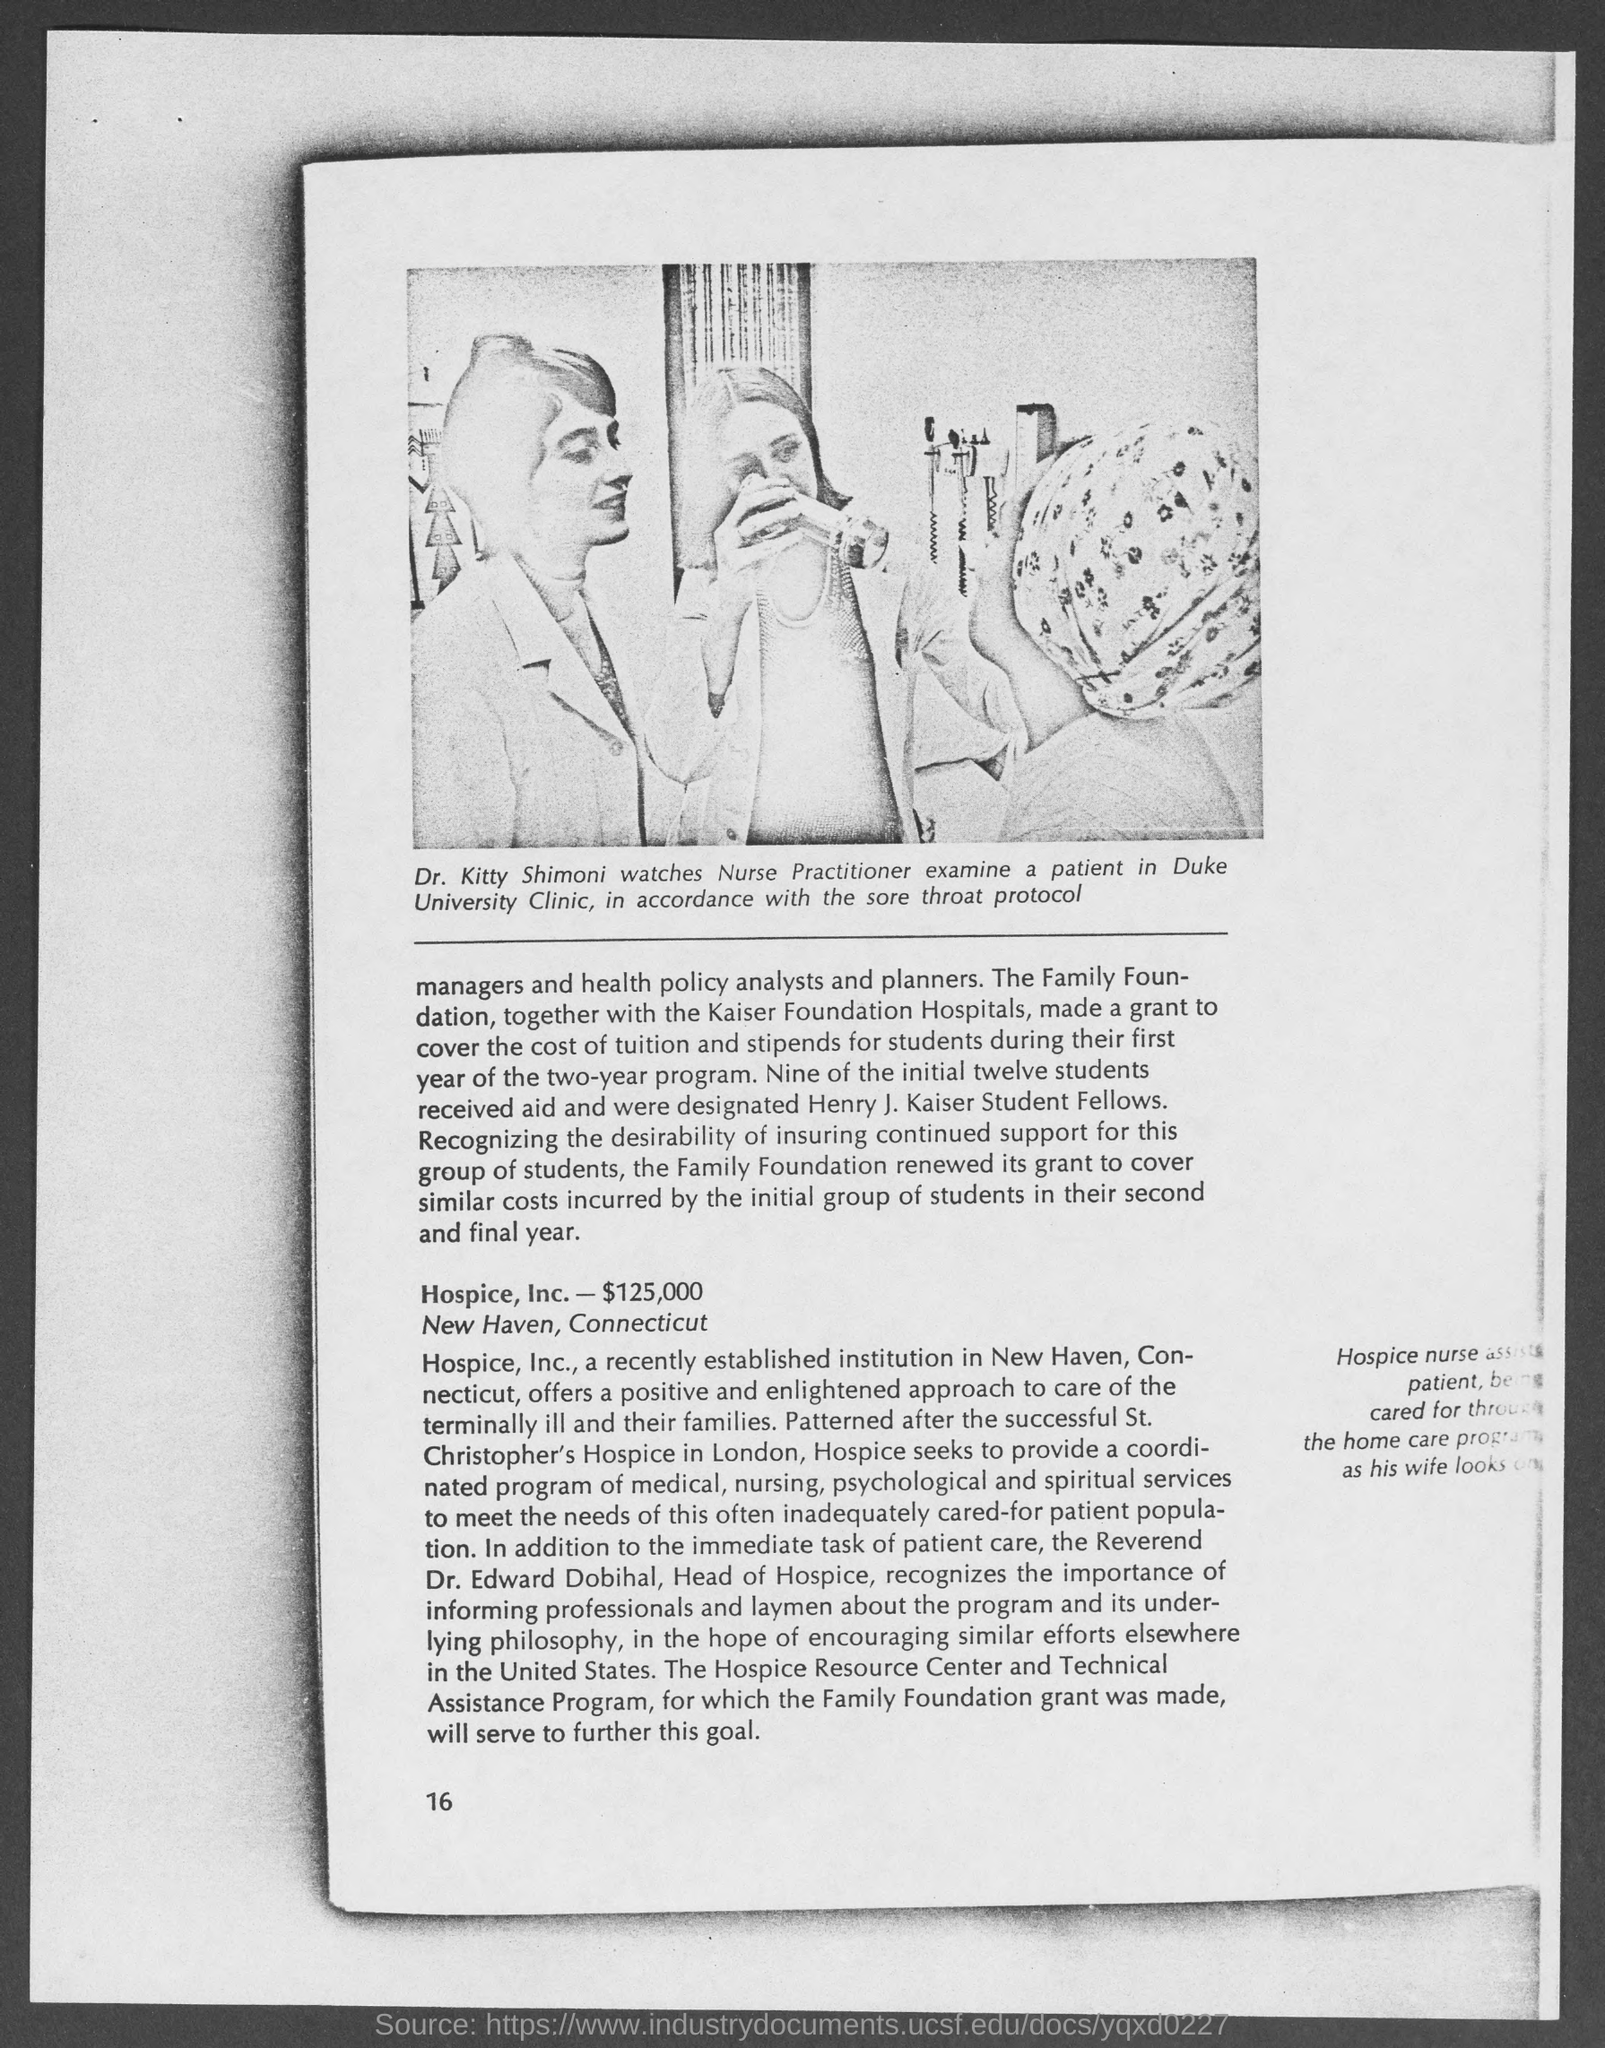Who is the doctor in the picture?
Your answer should be compact. Dr. Kitty Shimoni. In which clinic the patient is examined?
Make the answer very short. Duke University Clinic. Accordance with which protocol the patient is examined?
Make the answer very short. Sore throat protocol. The family foundation together with which hospitals made a grant to cover the cost of tuition and stipends for students?
Provide a succinct answer. Kaiser Foundation Hospitals. What were the nine students designated as?
Offer a very short reply. Henry j. kaiser student fellows. Where is hospice, inc.?
Provide a short and direct response. New Haven, connecticut. 